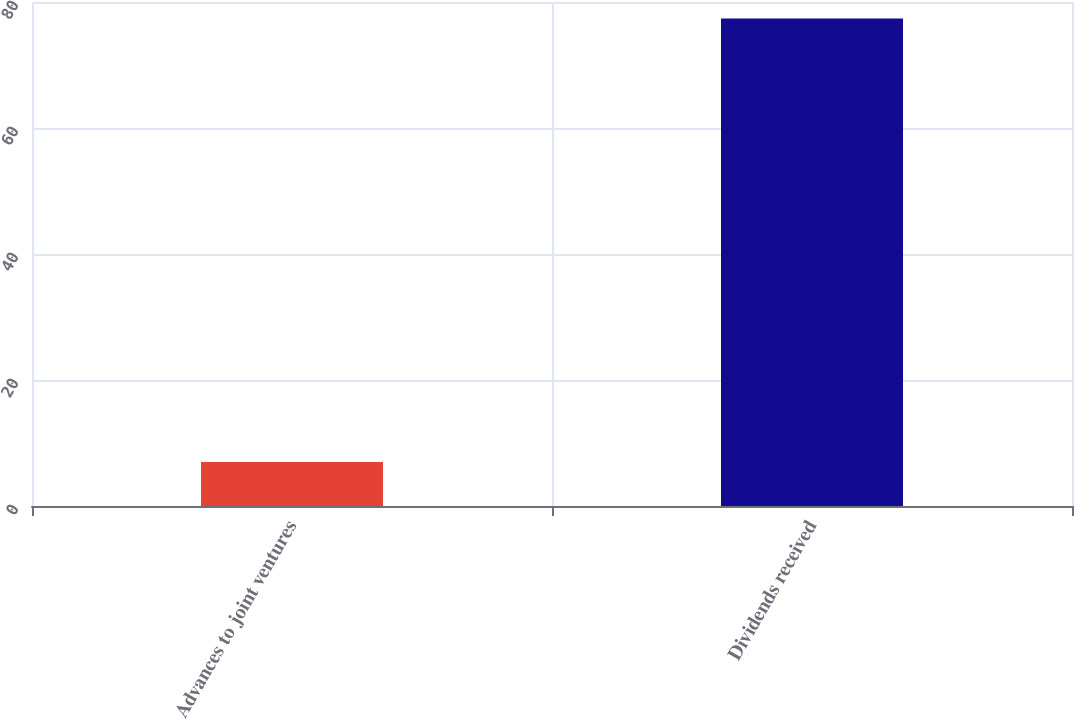Convert chart. <chart><loc_0><loc_0><loc_500><loc_500><bar_chart><fcel>Advances to joint ventures<fcel>Dividends received<nl><fcel>7<fcel>77.4<nl></chart> 